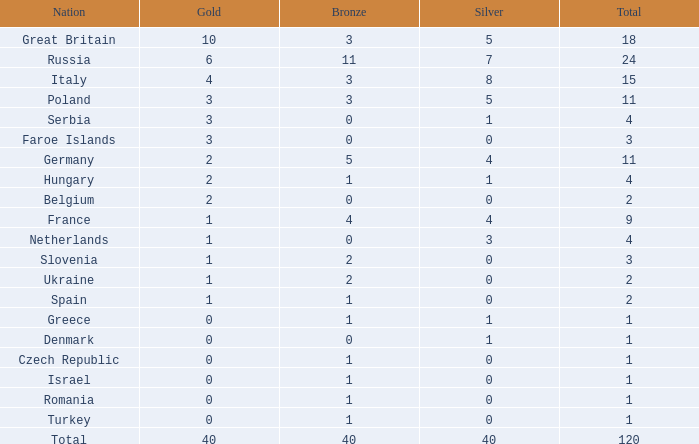What Nation has a Gold entry that is greater than 0, a Total that is greater than 2, a Silver entry that is larger than 1, and 0 Bronze? Netherlands. 